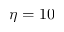Convert formula to latex. <formula><loc_0><loc_0><loc_500><loc_500>\eta = 1 0</formula> 